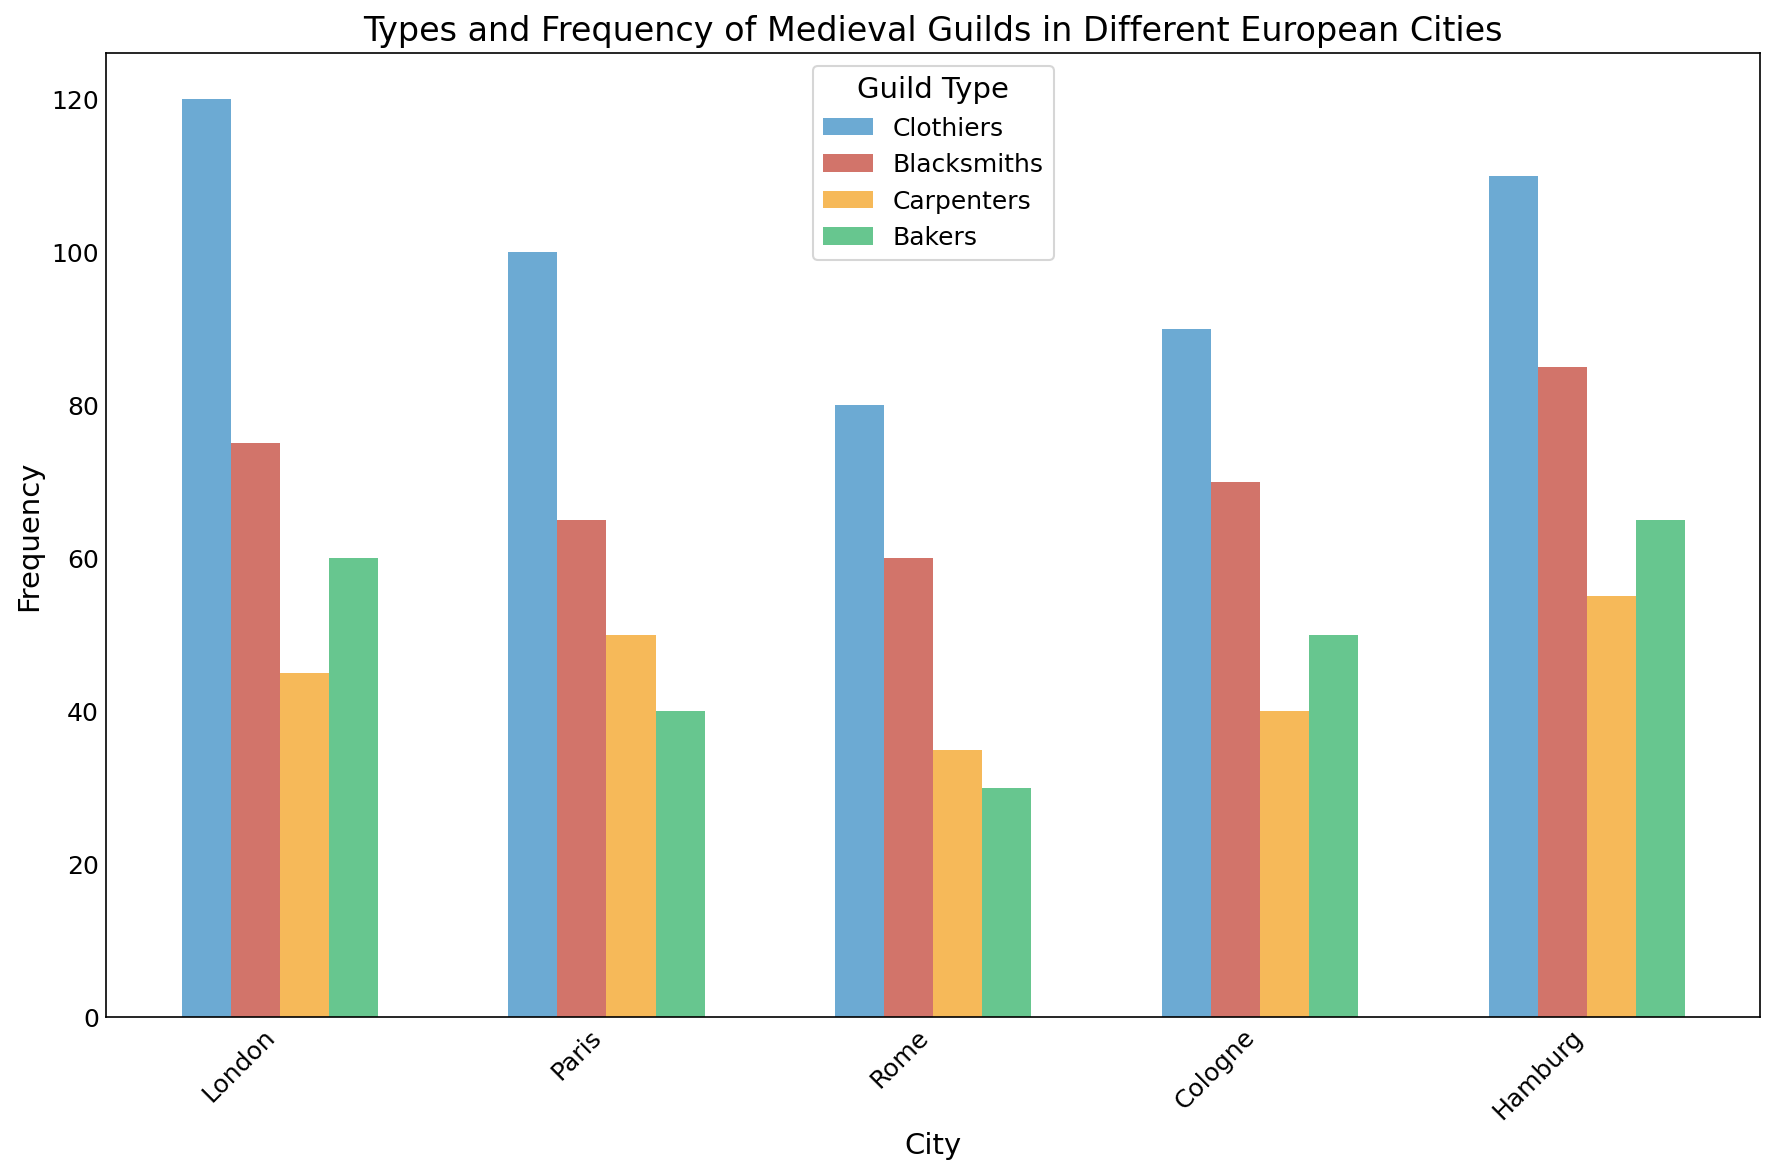Which city has the highest frequency of Clothiers? Identify and compare the heights of the bars representing Clothiers for each city: London, Paris, Rome, Cologne, and Hamburg. The bar for London is the tallest.
Answer: London Which Guild Type is the least frequent in Paris? Identify and compare the heights of the bars for each Guild Type in Paris: Clothiers, Blacksmiths, Carpenters, and Bakers. The bar for Bakers is the shortest.
Answer: Bakers What is the total frequency of Carpenters across all cities? Add the frequencies of Carpenters from each city: 45 (London) + 50 (Paris) + 35 (Rome) + 40 (Cologne) + 55 (Hamburg) = 225
Answer: 225 Which city has the smallest range in the frequencies of its guilds? Calculate the range for each city by finding the difference between the highest and lowest frequencies in that city and comparing them:  
- London: 120 - 45 = 75  
- Paris: 100 - 40 = 60  
- Rome: 80 - 30 = 50  
- Cologne: 90 - 40 = 50  
- Hamburg: 110 - 55 = 55  
Rome and Cologne both have the smallest range of 50.
Answer: Rome and Cologne Is the frequency of Blacksmiths in Hamburg greater than that of Bakers in London? Compare the height of the bar for Blacksmiths in Hamburg (85) with that of Bakers in London (60). 85 is greater than 60.
Answer: Yes Which city has the most balanced distribution of guild frequencies (least variation)? Calculate and compare the variations of frequencies in each city. The city with the frequencies that are closest to each other has the least variation.  
- London: (120, 75, 45, 60)  
- Paris: (100, 65, 50, 40)  
- Rome: (80, 60, 35, 30)  
- Cologne: (90, 70, 40, 50)  
- Hamburg: (110, 85, 55, 65)  
Analyze and visually inspect the mini-mum to maximum bars for each city. Based on the closeness of heights, Rome looks the most balanced.
Answer: Rome What is the sum of frequencies for all guilds in Cologne? Add the frequencies of all the guilds in Cologne: 90 (Clothiers) + 70 (Blacksmiths) + 40 (Carpenters) + 50 (Bakers) = 250
Answer: 250 How does the frequency of Bakers in Paris compare to that in Hamburg? Compare the heights of the bars for Bakers in Paris (40) and Hamburg (65). 65 is greater than 40.
Answer: Hamburg has higher What is the average frequency of Blacksmiths across all cities? Compute the average by adding the frequencies of Blacksmiths in each city and dividing by the number of cities: (75 + 65 + 60 + 70 + 85) / 5 = 71
Answer: 71 